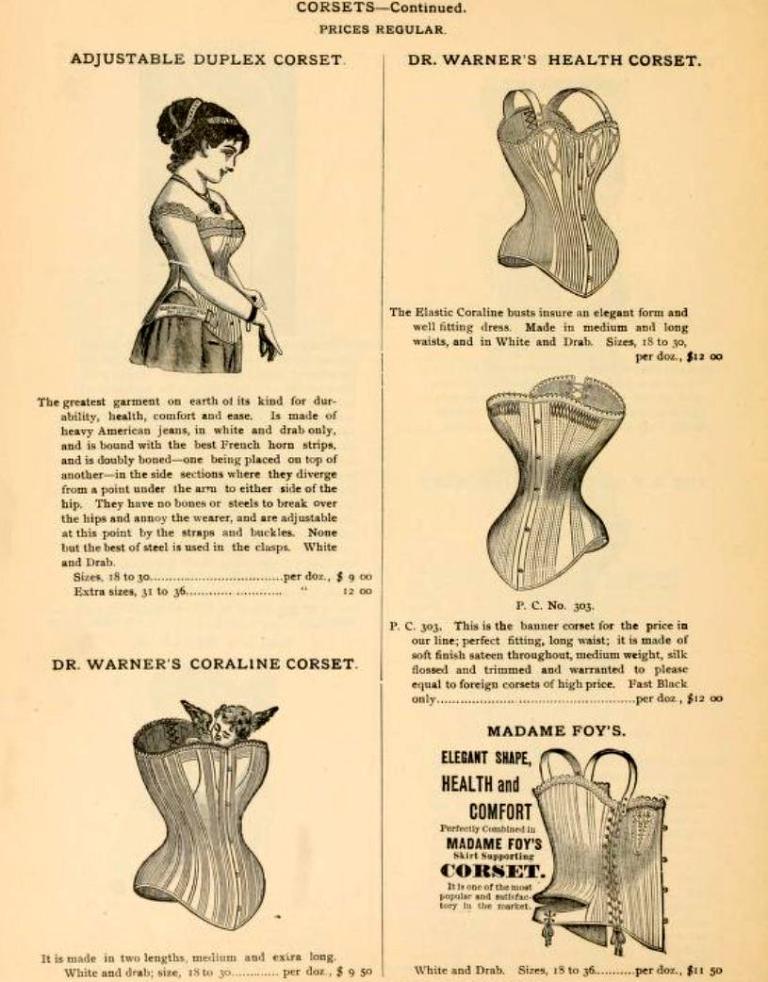Could you give a brief overview of what you see in this image? As we can see in the image there is a paper. On paper there is a woman and something written. 